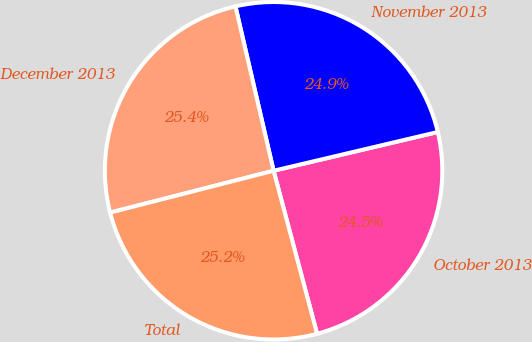<chart> <loc_0><loc_0><loc_500><loc_500><pie_chart><fcel>October 2013<fcel>November 2013<fcel>December 2013<fcel>Total<nl><fcel>24.54%<fcel>24.94%<fcel>25.36%<fcel>25.16%<nl></chart> 